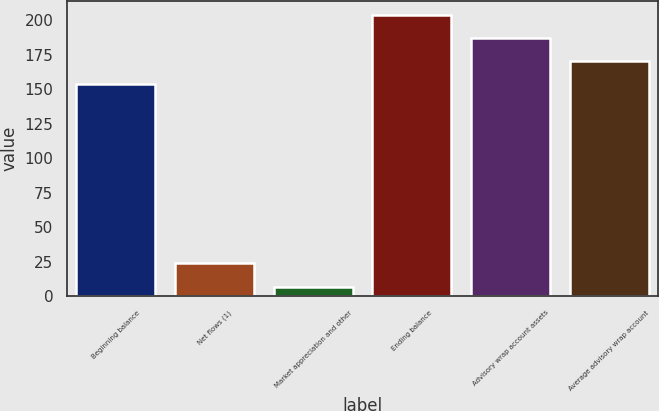<chart> <loc_0><loc_0><loc_500><loc_500><bar_chart><fcel>Beginning balance<fcel>Net flows (1)<fcel>Market appreciation and other<fcel>Ending balance<fcel>Advisory wrap account assets<fcel>Average advisory wrap account<nl><fcel>153.5<fcel>23.77<fcel>7<fcel>203.81<fcel>187.04<fcel>170.27<nl></chart> 